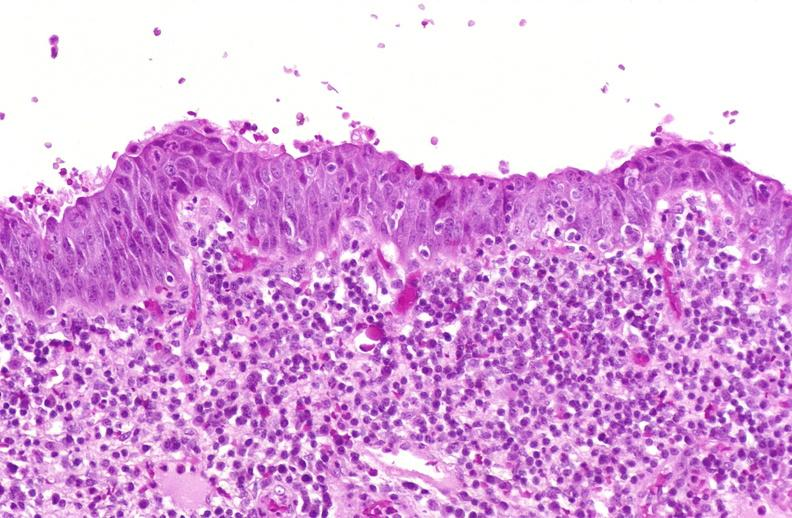s urinary present?
Answer the question using a single word or phrase. Yes 